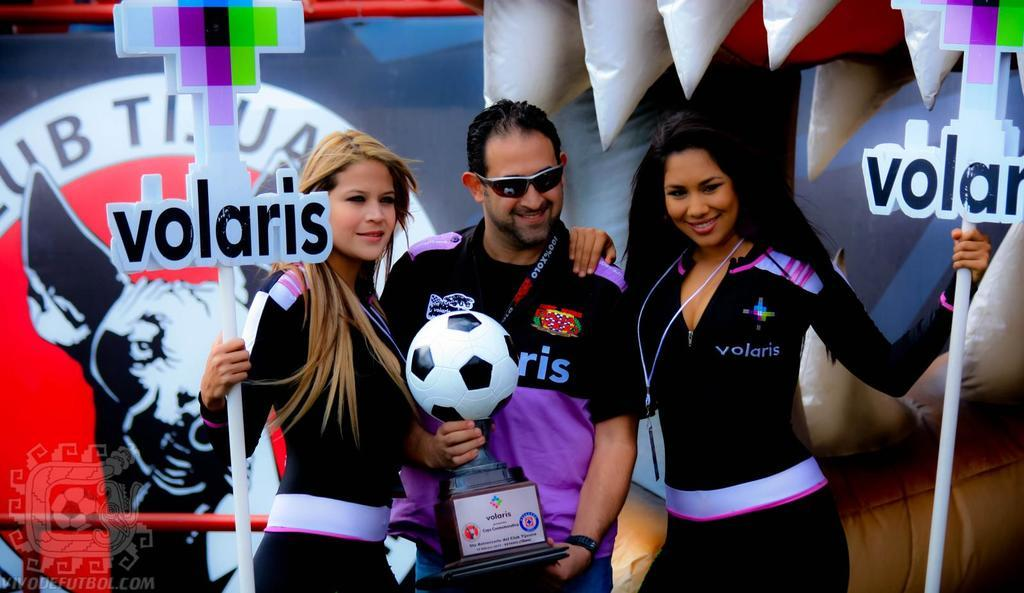<image>
Give a short and clear explanation of the subsequent image. Two people holding volaris signs stand with someone holding a soccer ball. 